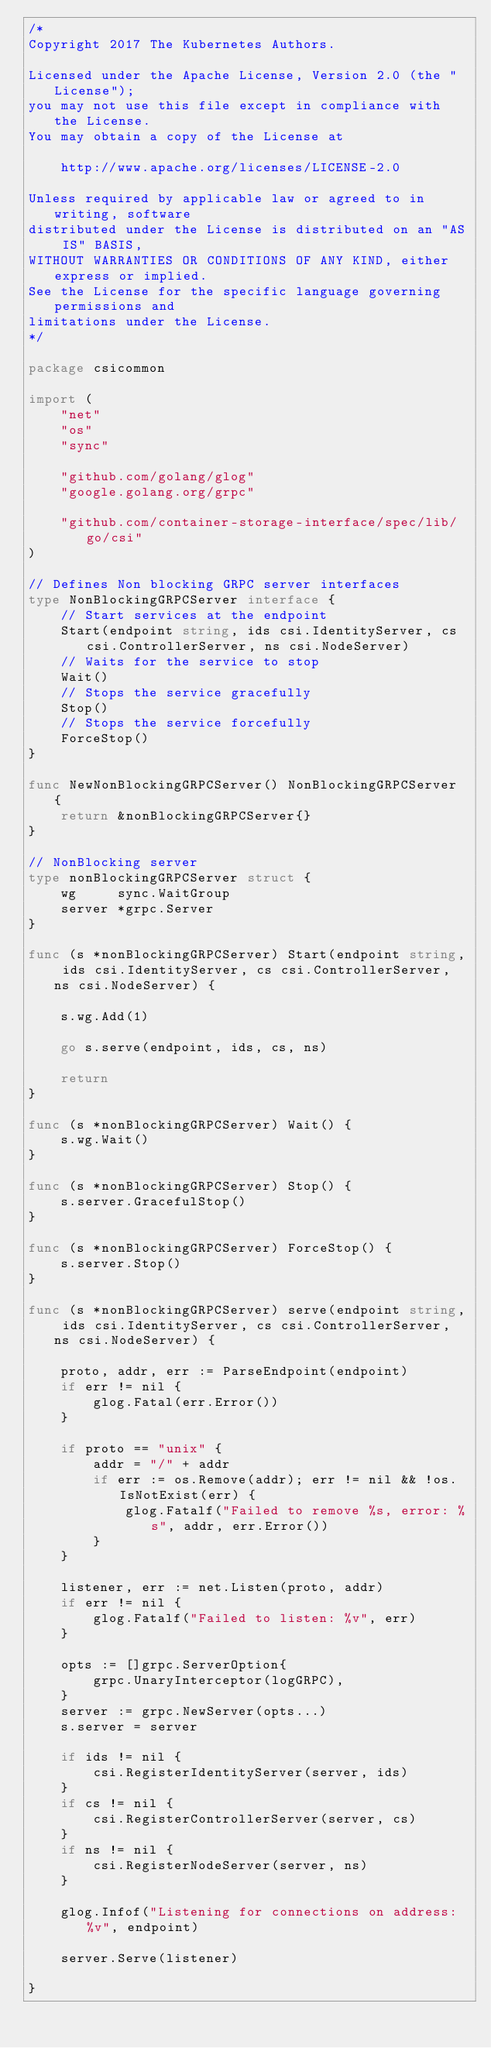Convert code to text. <code><loc_0><loc_0><loc_500><loc_500><_Go_>/*
Copyright 2017 The Kubernetes Authors.

Licensed under the Apache License, Version 2.0 (the "License");
you may not use this file except in compliance with the License.
You may obtain a copy of the License at

    http://www.apache.org/licenses/LICENSE-2.0

Unless required by applicable law or agreed to in writing, software
distributed under the License is distributed on an "AS IS" BASIS,
WITHOUT WARRANTIES OR CONDITIONS OF ANY KIND, either express or implied.
See the License for the specific language governing permissions and
limitations under the License.
*/

package csicommon

import (
	"net"
	"os"
	"sync"

	"github.com/golang/glog"
	"google.golang.org/grpc"

	"github.com/container-storage-interface/spec/lib/go/csi"
)

// Defines Non blocking GRPC server interfaces
type NonBlockingGRPCServer interface {
	// Start services at the endpoint
	Start(endpoint string, ids csi.IdentityServer, cs csi.ControllerServer, ns csi.NodeServer)
	// Waits for the service to stop
	Wait()
	// Stops the service gracefully
	Stop()
	// Stops the service forcefully
	ForceStop()
}

func NewNonBlockingGRPCServer() NonBlockingGRPCServer {
	return &nonBlockingGRPCServer{}
}

// NonBlocking server
type nonBlockingGRPCServer struct {
	wg     sync.WaitGroup
	server *grpc.Server
}

func (s *nonBlockingGRPCServer) Start(endpoint string, ids csi.IdentityServer, cs csi.ControllerServer, ns csi.NodeServer) {

	s.wg.Add(1)

	go s.serve(endpoint, ids, cs, ns)

	return
}

func (s *nonBlockingGRPCServer) Wait() {
	s.wg.Wait()
}

func (s *nonBlockingGRPCServer) Stop() {
	s.server.GracefulStop()
}

func (s *nonBlockingGRPCServer) ForceStop() {
	s.server.Stop()
}

func (s *nonBlockingGRPCServer) serve(endpoint string, ids csi.IdentityServer, cs csi.ControllerServer, ns csi.NodeServer) {

	proto, addr, err := ParseEndpoint(endpoint)
	if err != nil {
		glog.Fatal(err.Error())
	}

	if proto == "unix" {
		addr = "/" + addr
		if err := os.Remove(addr); err != nil && !os.IsNotExist(err) {
			glog.Fatalf("Failed to remove %s, error: %s", addr, err.Error())
		}
	}

	listener, err := net.Listen(proto, addr)
	if err != nil {
		glog.Fatalf("Failed to listen: %v", err)
	}

	opts := []grpc.ServerOption{
		grpc.UnaryInterceptor(logGRPC),
	}
	server := grpc.NewServer(opts...)
	s.server = server

	if ids != nil {
		csi.RegisterIdentityServer(server, ids)
	}
	if cs != nil {
		csi.RegisterControllerServer(server, cs)
	}
	if ns != nil {
		csi.RegisterNodeServer(server, ns)
	}

	glog.Infof("Listening for connections on address: %v", endpoint)

	server.Serve(listener)

}
</code> 